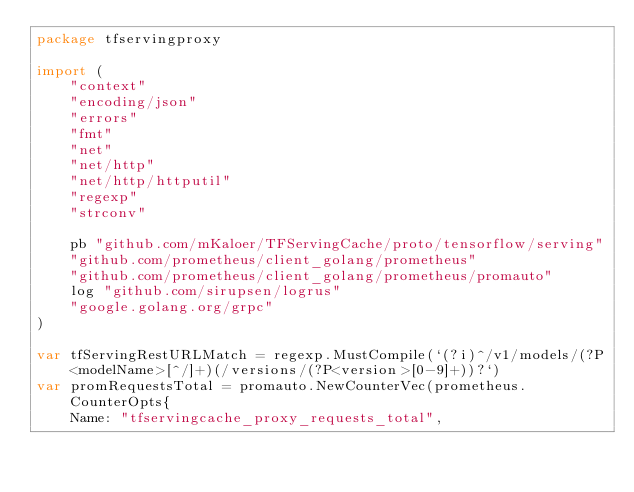Convert code to text. <code><loc_0><loc_0><loc_500><loc_500><_Go_>package tfservingproxy

import (
	"context"
	"encoding/json"
	"errors"
	"fmt"
	"net"
	"net/http"
	"net/http/httputil"
	"regexp"
	"strconv"

	pb "github.com/mKaloer/TFServingCache/proto/tensorflow/serving"
	"github.com/prometheus/client_golang/prometheus"
	"github.com/prometheus/client_golang/prometheus/promauto"
	log "github.com/sirupsen/logrus"
	"google.golang.org/grpc"
)

var tfServingRestURLMatch = regexp.MustCompile(`(?i)^/v1/models/(?P<modelName>[^/]+)(/versions/(?P<version>[0-9]+))?`)
var promRequestsTotal = promauto.NewCounterVec(prometheus.CounterOpts{
	Name: "tfservingcache_proxy_requests_total",</code> 